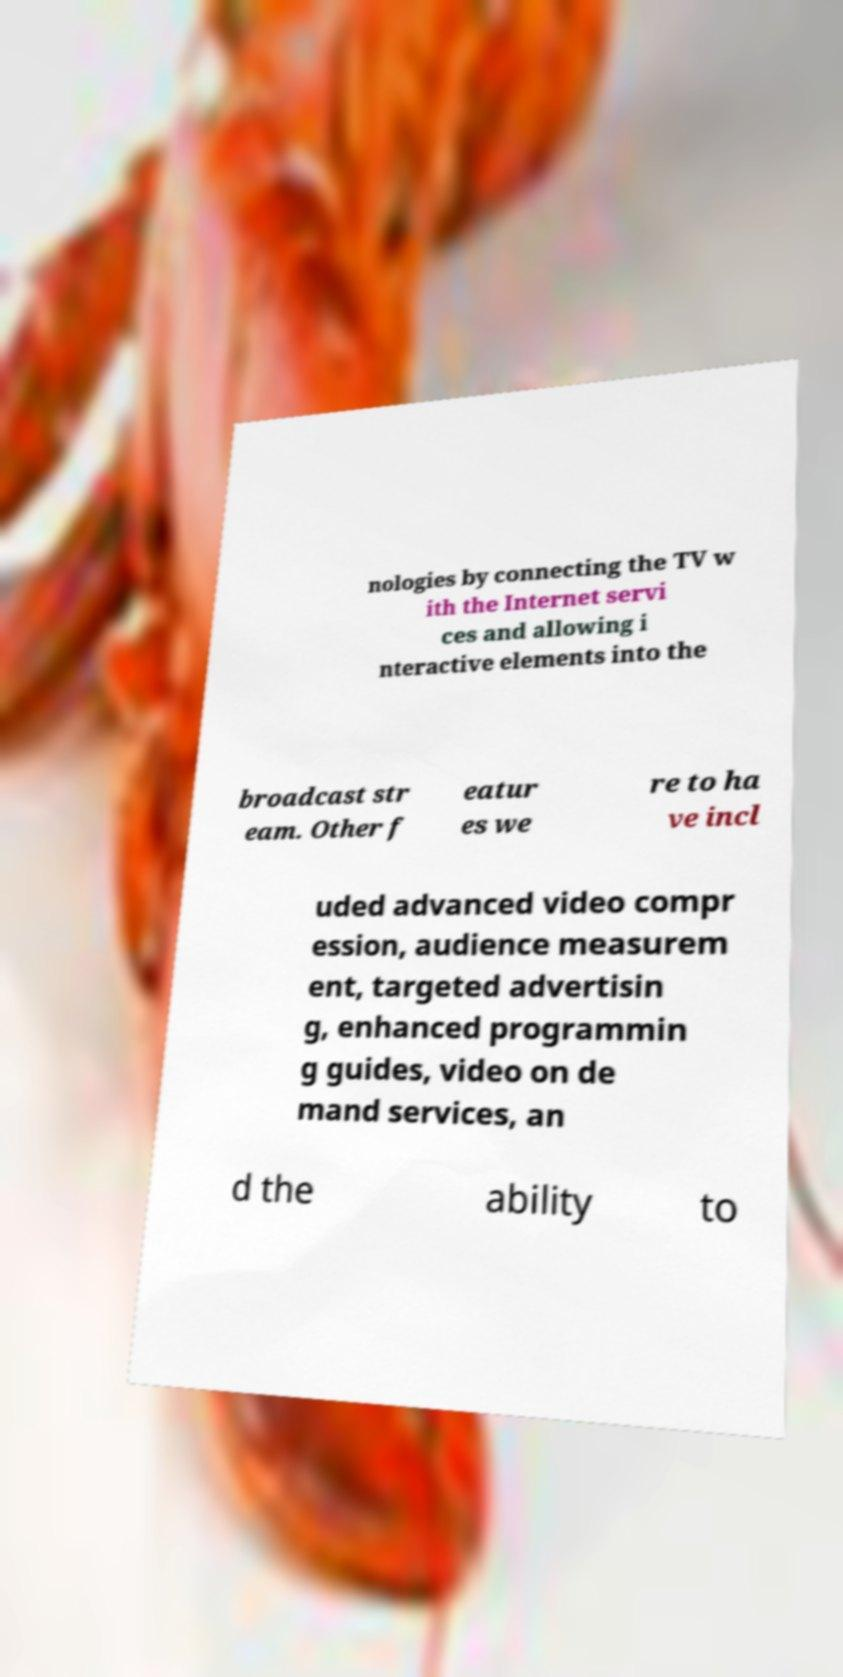Can you accurately transcribe the text from the provided image for me? nologies by connecting the TV w ith the Internet servi ces and allowing i nteractive elements into the broadcast str eam. Other f eatur es we re to ha ve incl uded advanced video compr ession, audience measurem ent, targeted advertisin g, enhanced programmin g guides, video on de mand services, an d the ability to 